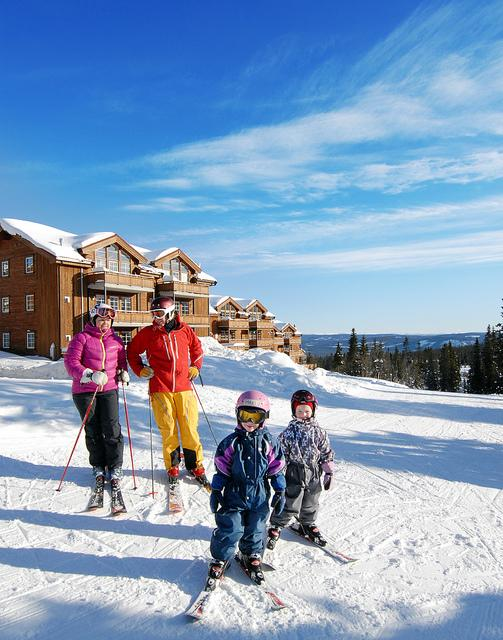Who are the adults standing behind the children? parents 